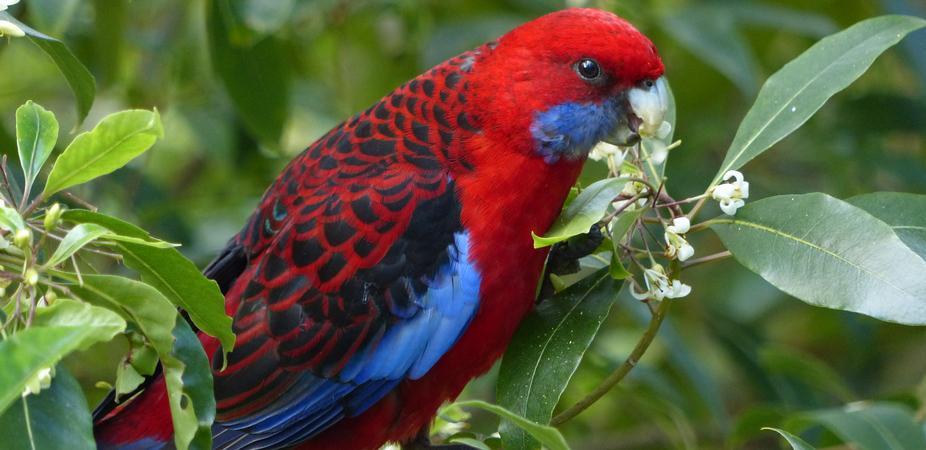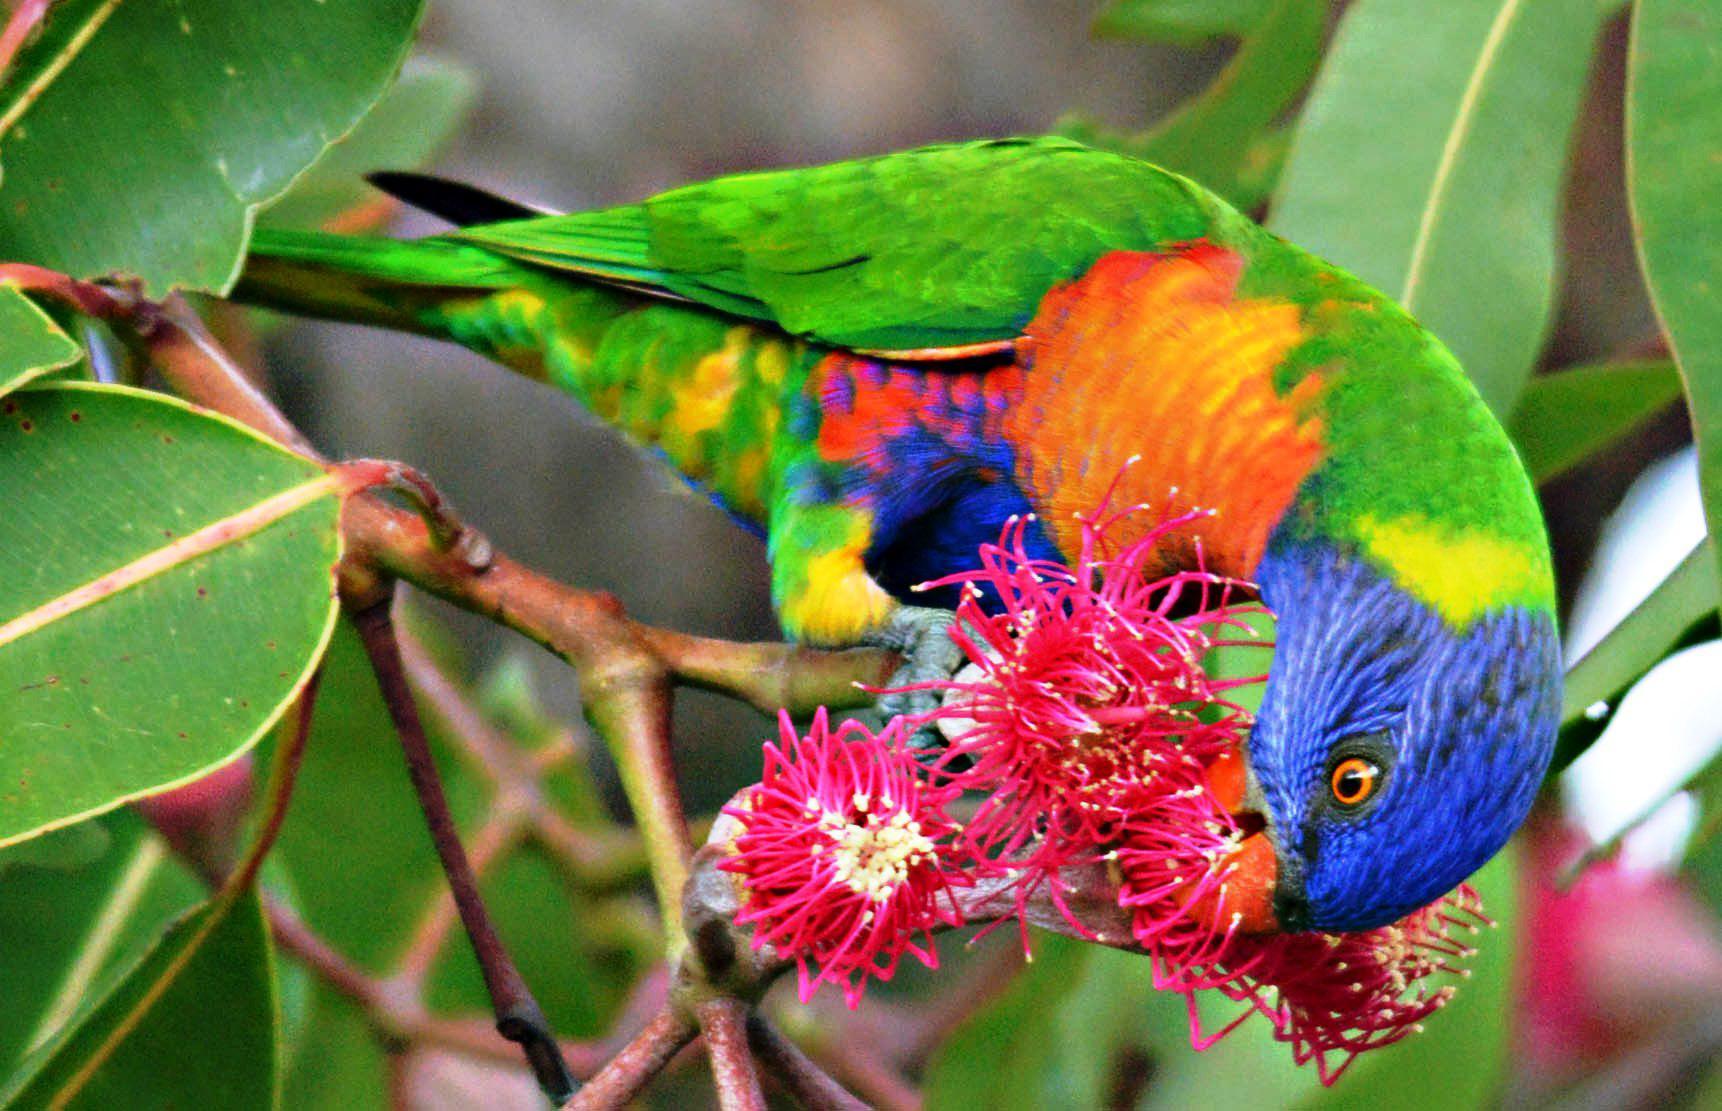The first image is the image on the left, the second image is the image on the right. For the images shown, is this caption "In the image to the left, the bird is eating from a flower." true? Answer yes or no. Yes. The first image is the image on the left, the second image is the image on the right. For the images shown, is this caption "There is a total of 1 parrot perched on magenta colored flowers." true? Answer yes or no. Yes. 